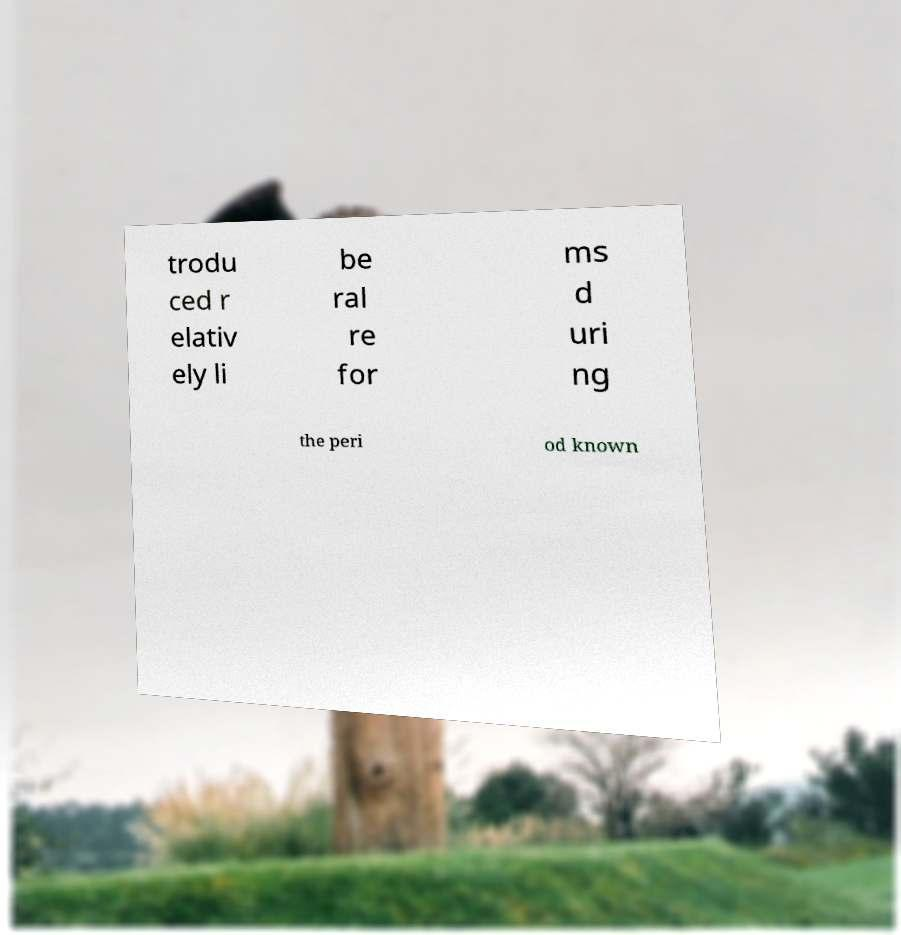For documentation purposes, I need the text within this image transcribed. Could you provide that? trodu ced r elativ ely li be ral re for ms d uri ng the peri od known 